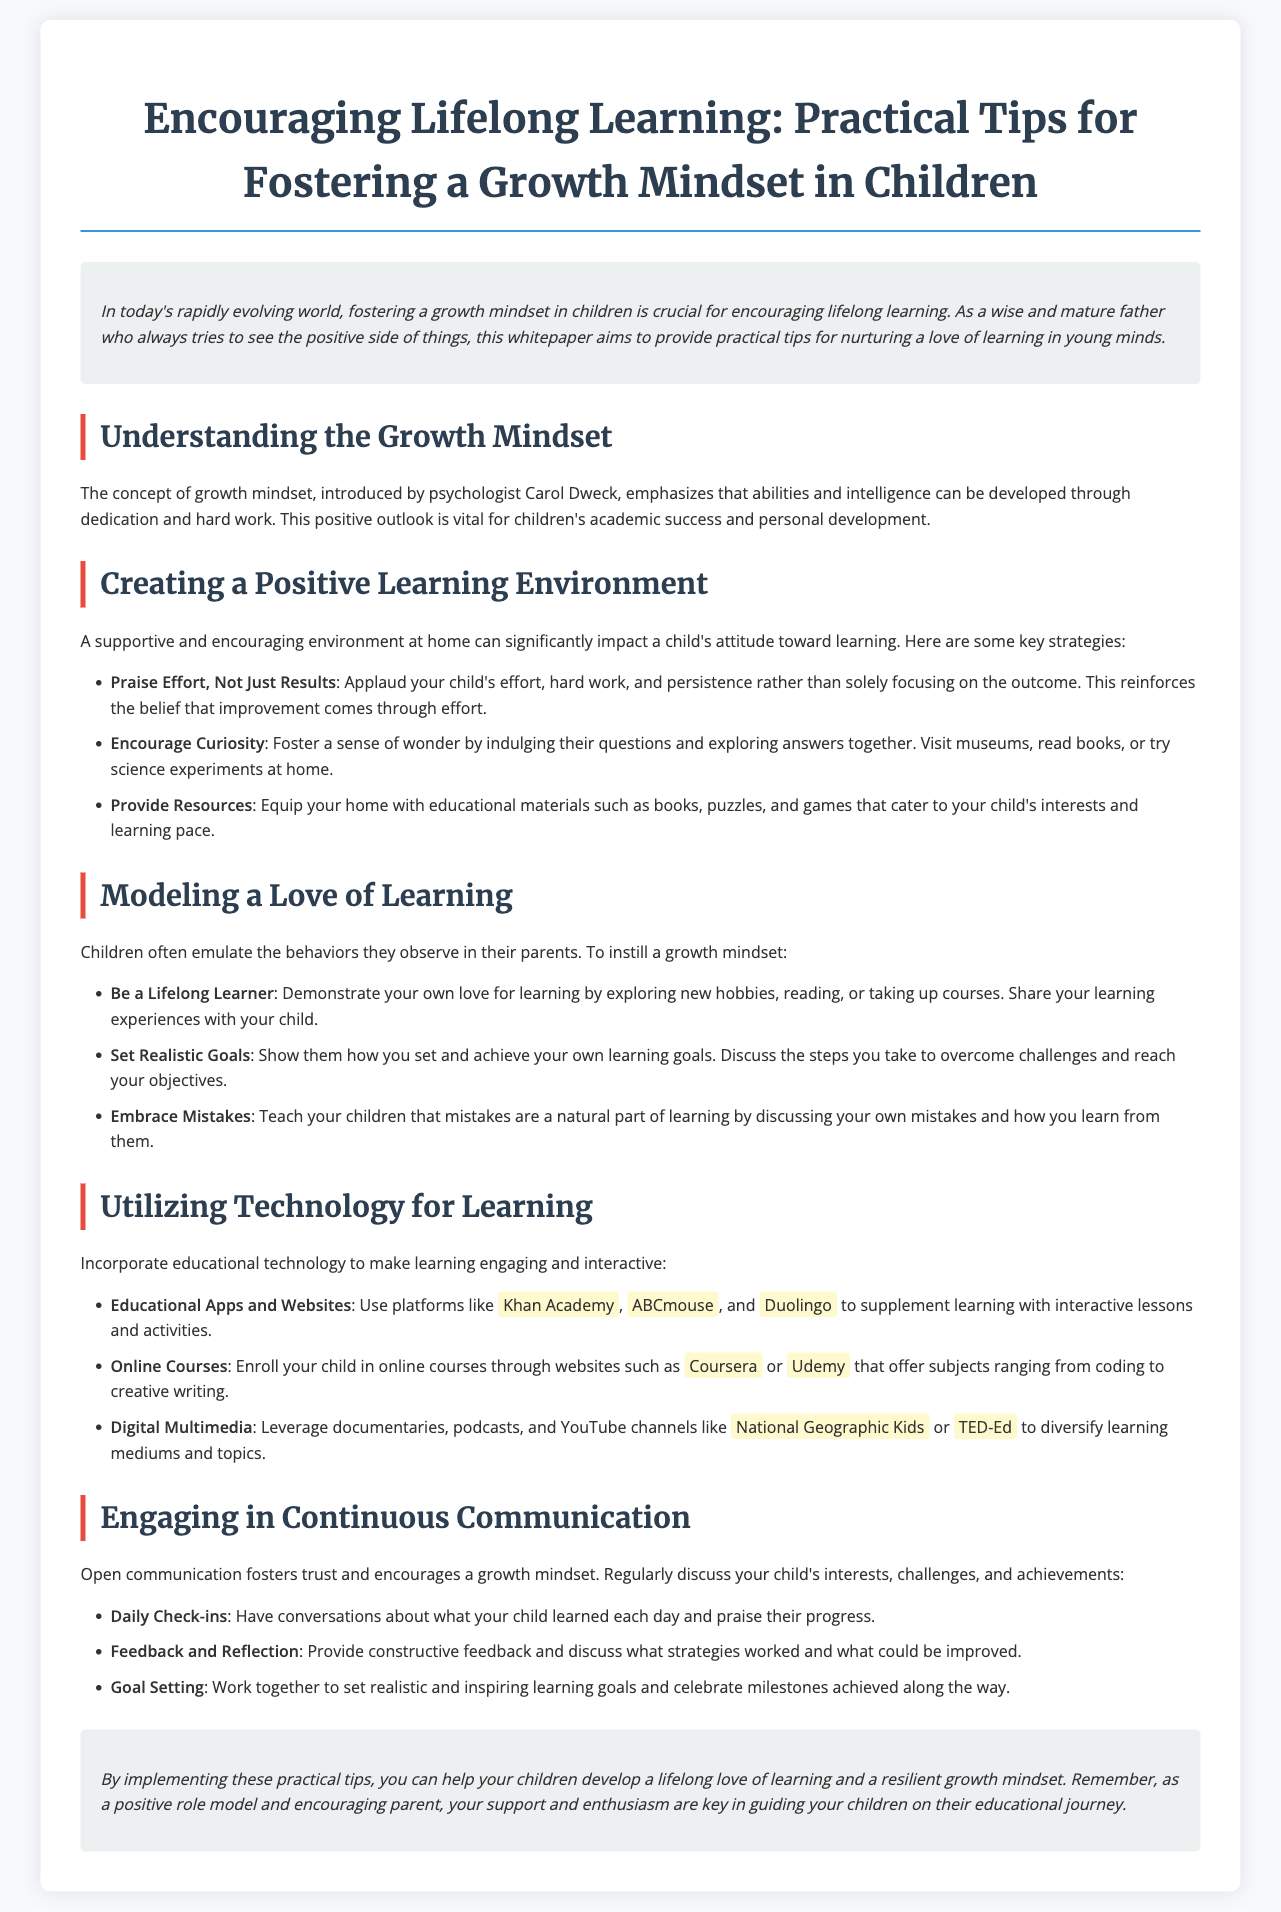What is the title of the whitepaper? The title is explicitly stated at the beginning of the document, providing the main focus.
Answer: Encouraging Lifelong Learning: Practical Tips for Fostering a Growth Mindset in Children Who introduced the concept of growth mindset? The document mentions psychologist Carol Dweck as the introducer of the growth mindset concept.
Answer: Carol Dweck What should parents praise in their children? The whitepaper emphasizes praising effort rather than just results to reinforce a growth mindset.
Answer: Effort Name one educational app mentioned in the document. The document lists several apps, one of which is specified to be used for educational purposes.
Answer: Khan Academy What is a key strategy for creating a positive learning environment? One strategy highlighted in the document for fostering a healthy learning environment is to encourage children's innate inquisitiveness.
Answer: Encourage Curiosity What type of setting is recommended for having daily check-ins with children? The document suggests regular discussions about learning, which typically occur in a supportive context at home.
Answer: Home What is a recommended way to model a love of learning? The document states that parents should demonstrate their own passions for learning as an effective model for children.
Answer: Be a Lifelong Learner How should mistakes be viewed according to the whitepaper? The document advises that mistakes are a natural and valuable part of the learning process.
Answer: Embrace Mistakes 